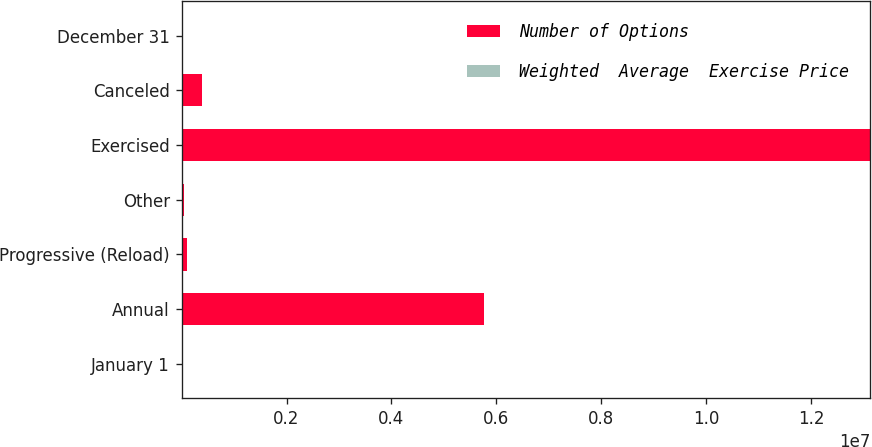<chart> <loc_0><loc_0><loc_500><loc_500><stacked_bar_chart><ecel><fcel>January 1<fcel>Annual<fcel>Progressive (Reload)<fcel>Other<fcel>Exercised<fcel>Canceled<fcel>December 31<nl><fcel>Number of Options<fcel>89.45<fcel>5.77019e+06<fcel>110065<fcel>51661<fcel>1.31236e+07<fcel>391684<fcel>89.45<nl><fcel>Weighted  Average  Exercise Price<fcel>77.28<fcel>87.91<fcel>89.65<fcel>89.25<fcel>68.78<fcel>83.65<fcel>80.33<nl></chart> 